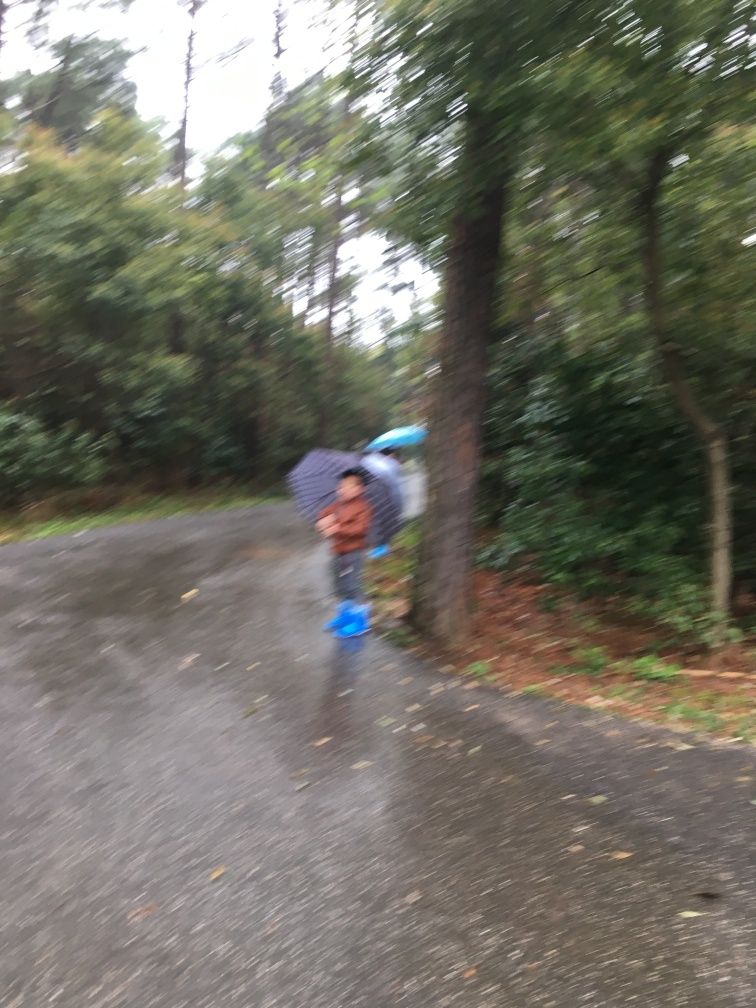Can you describe the weather conditions in this image? The weather appears to be overcast with possible rain, indicated by the presence of an umbrella and the wetness on the ground. 